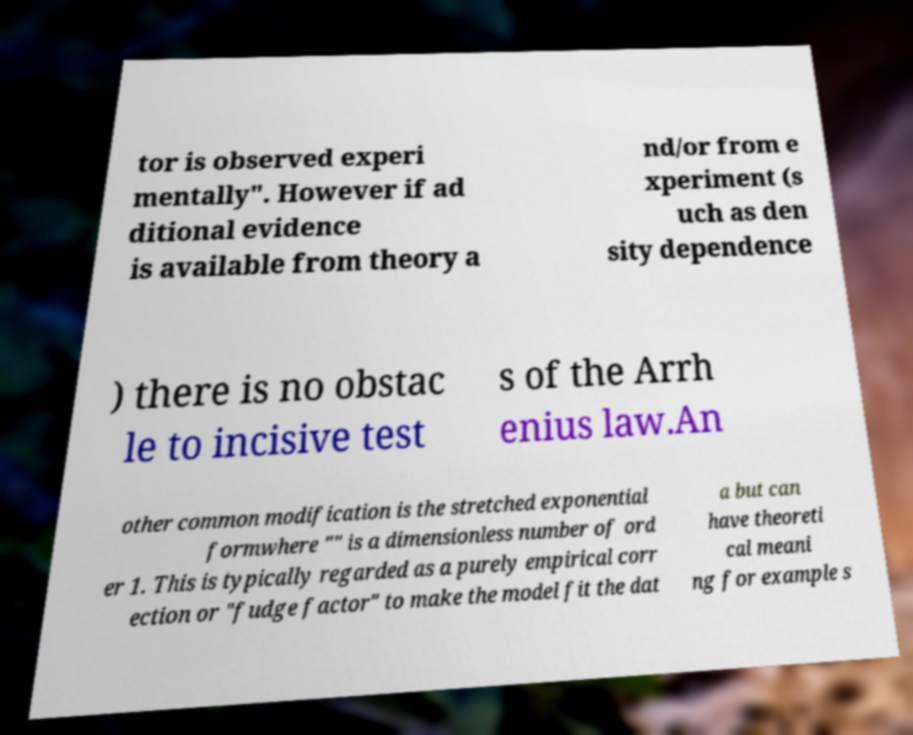There's text embedded in this image that I need extracted. Can you transcribe it verbatim? tor is observed experi mentally". However if ad ditional evidence is available from theory a nd/or from e xperiment (s uch as den sity dependence ) there is no obstac le to incisive test s of the Arrh enius law.An other common modification is the stretched exponential formwhere "" is a dimensionless number of ord er 1. This is typically regarded as a purely empirical corr ection or "fudge factor" to make the model fit the dat a but can have theoreti cal meani ng for example s 